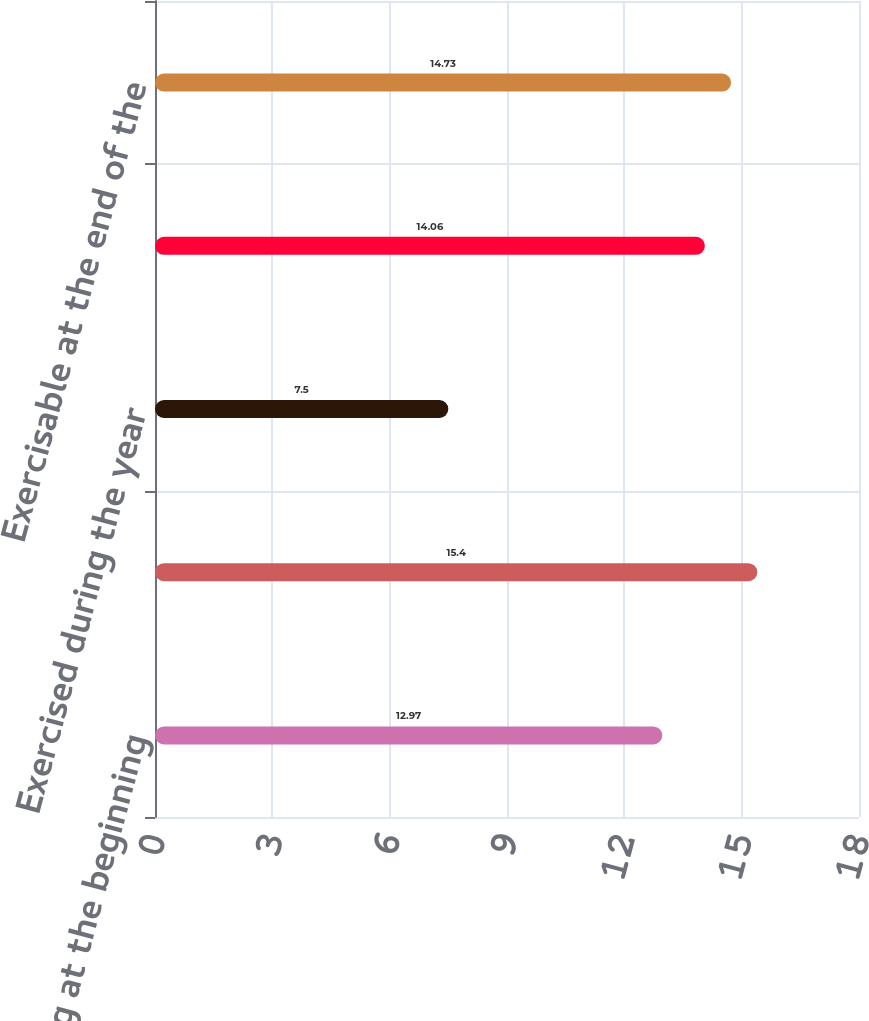Convert chart to OTSL. <chart><loc_0><loc_0><loc_500><loc_500><bar_chart><fcel>Outstanding at the beginning<fcel>Forfeited during the year<fcel>Exercised during the year<fcel>Outstanding at the end of the<fcel>Exercisable at the end of the<nl><fcel>12.97<fcel>15.4<fcel>7.5<fcel>14.06<fcel>14.73<nl></chart> 